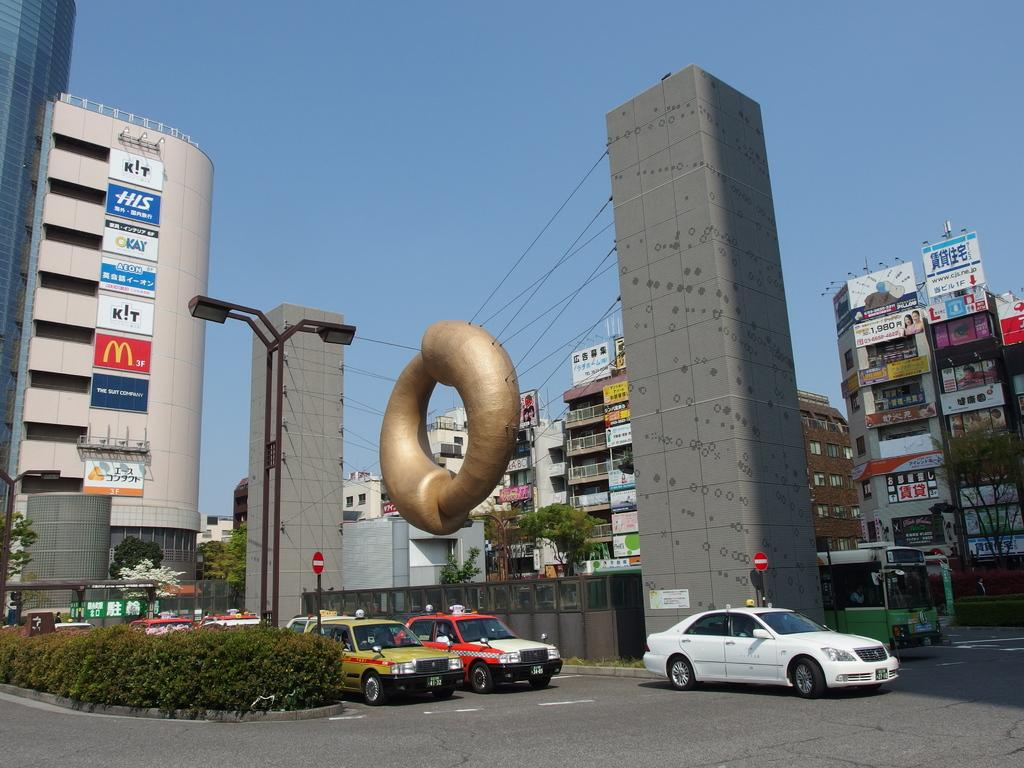Provide a one-sentence caption for the provided image. A city street has cars waiting to enter an intersection and a sign that says Okay. 